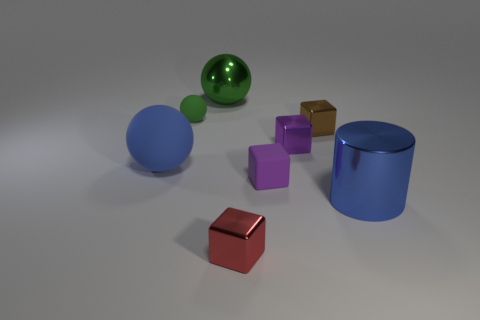Do the object behind the green rubber ball and the tiny brown block have the same size?
Provide a short and direct response. No. How many brown metal things are behind the big thing that is behind the large blue object on the left side of the red cube?
Offer a very short reply. 0. What number of blue things are big cylinders or matte spheres?
Your answer should be compact. 2. What color is the large thing that is made of the same material as the blue cylinder?
Provide a succinct answer. Green. Is there anything else that has the same size as the green rubber object?
Provide a short and direct response. Yes. How many small objects are purple matte cylinders or brown cubes?
Your answer should be very brief. 1. Is the number of brown things less than the number of green metal blocks?
Give a very brief answer. No. The tiny thing that is the same shape as the big blue matte thing is what color?
Offer a very short reply. Green. Are there any other things that are the same shape as the small brown thing?
Your answer should be compact. Yes. Are there more large blue rubber things than red metallic cylinders?
Your answer should be very brief. Yes. 